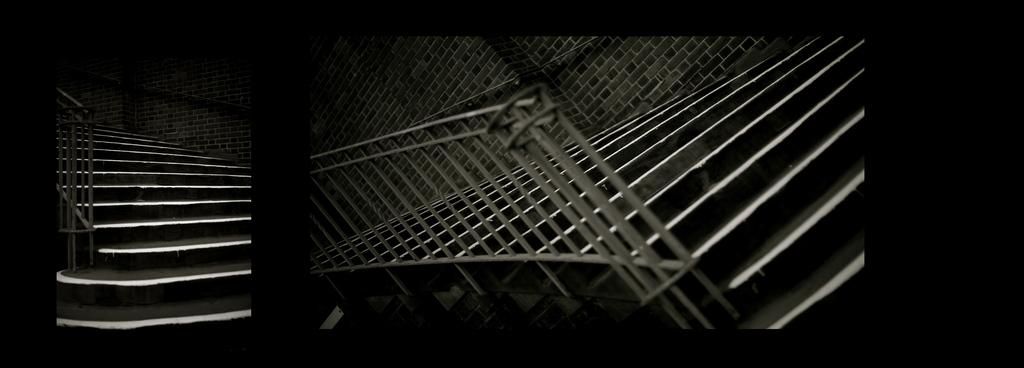How many images are included in the collage? The collage contains two images. What elements can be found in both images? In both images, there are stairs, handrails, and walls. What is the color of the background in the collage? The background of the collage is in black color. Can you hear a whistle in the image? There is no whistle present in the image; it is a visual representation of stairs, handrails, and walls. Is there any salt visible in the image? There is no salt present in the image. 